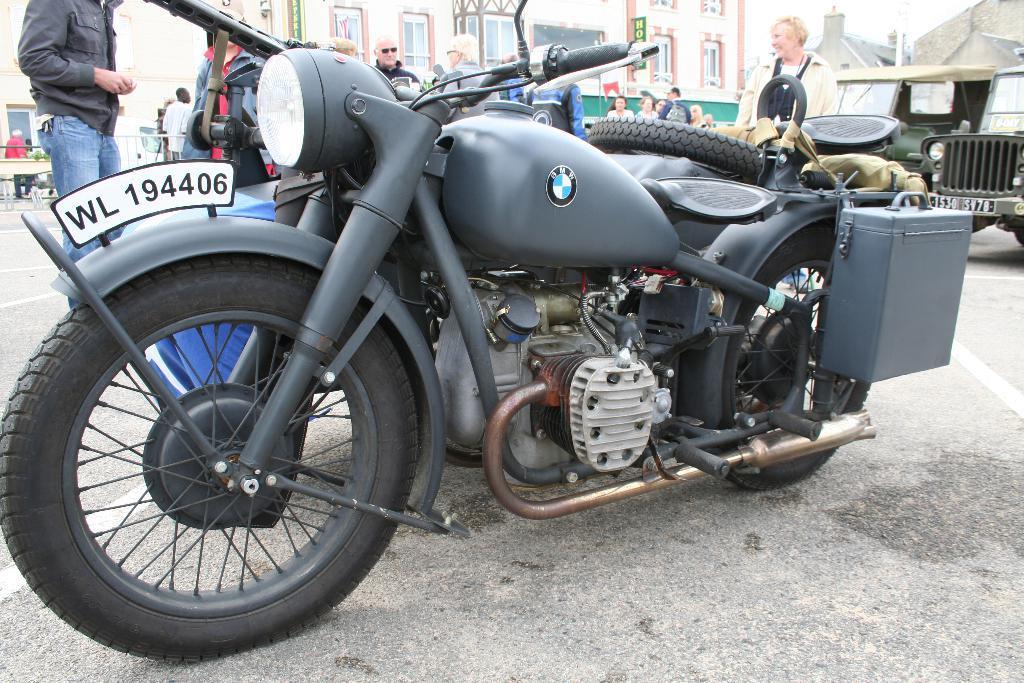In one or two sentences, can you explain what this image depicts? In the middle of the picture, we see the bike in grey color is parked on the road. On the right side, we see the vehicles parked on the road. Beside that, we see people are standing on the road. There are buildings in the background. On the left side, we see a man is standing beside the bench. At the bottom, we see the road. This picture is clicked outside the city. 